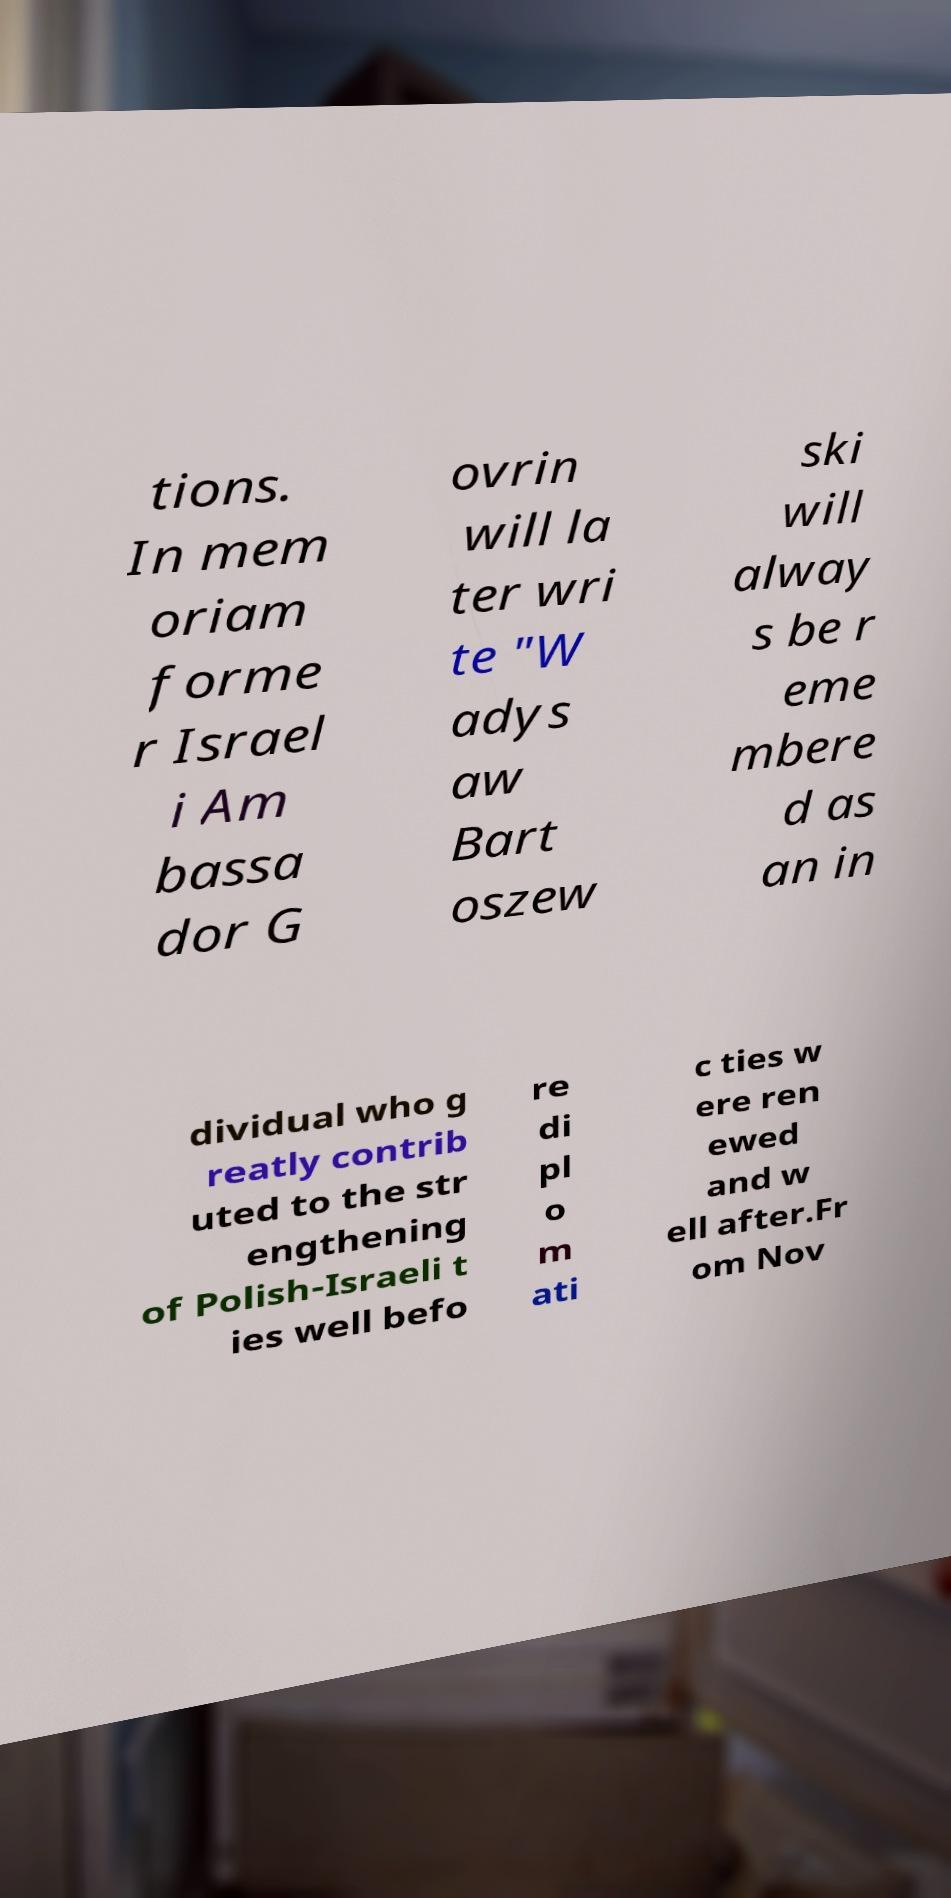Please identify and transcribe the text found in this image. tions. In mem oriam forme r Israel i Am bassa dor G ovrin will la ter wri te "W adys aw Bart oszew ski will alway s be r eme mbere d as an in dividual who g reatly contrib uted to the str engthening of Polish-Israeli t ies well befo re di pl o m ati c ties w ere ren ewed and w ell after.Fr om Nov 